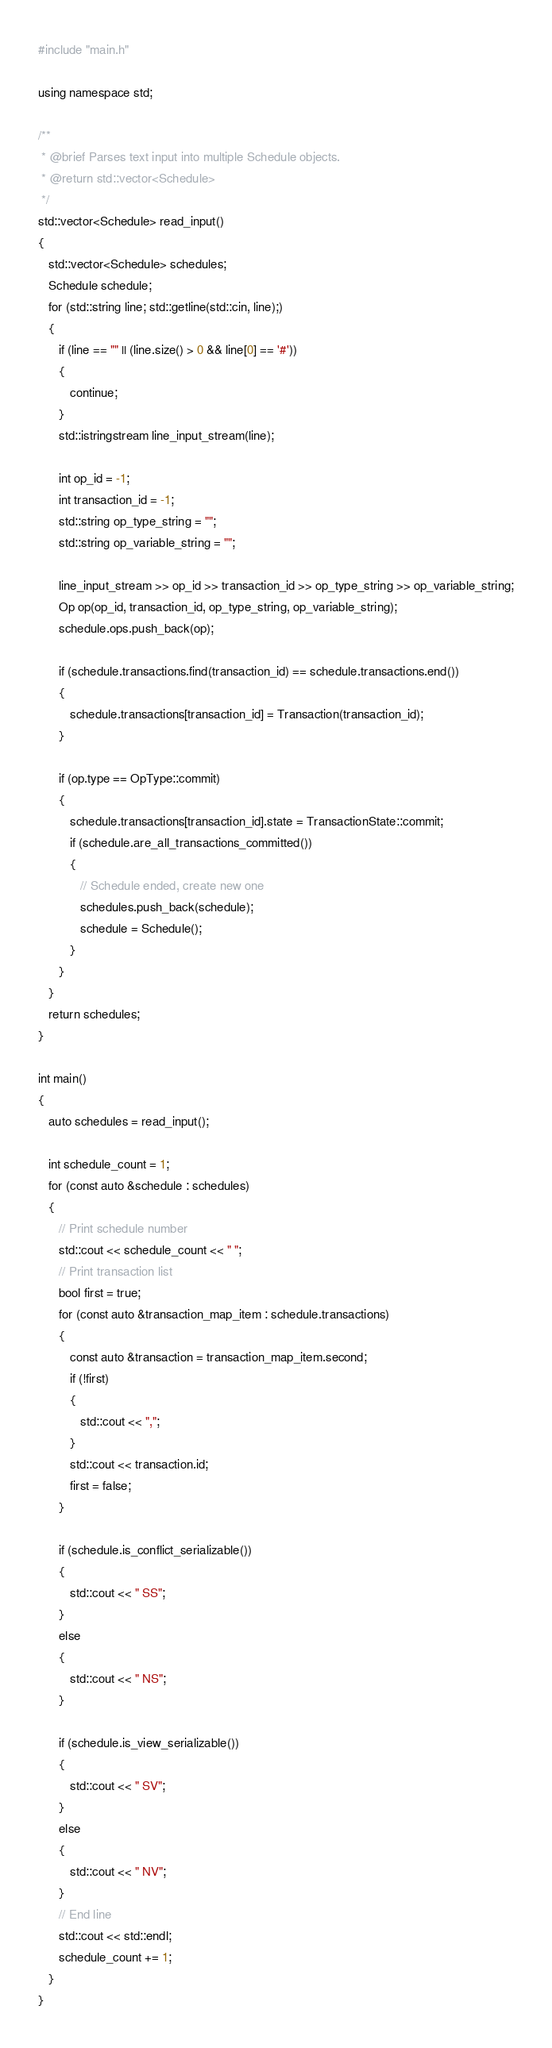Convert code to text. <code><loc_0><loc_0><loc_500><loc_500><_C++_>
#include "main.h"

using namespace std;

/**
 * @brief Parses text input into multiple Schedule objects.
 * @return std::vector<Schedule> 
 */
std::vector<Schedule> read_input()
{
   std::vector<Schedule> schedules;
   Schedule schedule;
   for (std::string line; std::getline(std::cin, line);)
   {
      if (line == "" || (line.size() > 0 && line[0] == '#'))
      {
         continue;
      }
      std::istringstream line_input_stream(line);

      int op_id = -1;
      int transaction_id = -1;
      std::string op_type_string = "";
      std::string op_variable_string = "";

      line_input_stream >> op_id >> transaction_id >> op_type_string >> op_variable_string;
      Op op(op_id, transaction_id, op_type_string, op_variable_string);
      schedule.ops.push_back(op);

      if (schedule.transactions.find(transaction_id) == schedule.transactions.end())
      {
         schedule.transactions[transaction_id] = Transaction(transaction_id);
      }

      if (op.type == OpType::commit)
      {
         schedule.transactions[transaction_id].state = TransactionState::commit;
         if (schedule.are_all_transactions_committed())
         {
            // Schedule ended, create new one
            schedules.push_back(schedule);
            schedule = Schedule();
         }
      }
   }
   return schedules;
}

int main()
{
   auto schedules = read_input();

   int schedule_count = 1;
   for (const auto &schedule : schedules)
   {
      // Print schedule number
      std::cout << schedule_count << " ";
      // Print transaction list
      bool first = true;
      for (const auto &transaction_map_item : schedule.transactions)
      {
         const auto &transaction = transaction_map_item.second;
         if (!first)
         {
            std::cout << ",";
         }
         std::cout << transaction.id;
         first = false;
      }

      if (schedule.is_conflict_serializable())
      {
         std::cout << " SS";
      }
      else
      {
         std::cout << " NS";
      }

      if (schedule.is_view_serializable())
      {
         std::cout << " SV";
      }
      else
      {
         std::cout << " NV";
      }
      // End line
      std::cout << std::endl;
      schedule_count += 1;
   }
}</code> 